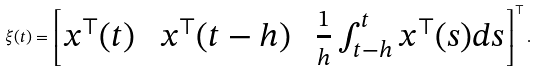<formula> <loc_0><loc_0><loc_500><loc_500>\xi ( t ) = \left [ \begin{matrix} x ^ { \top } ( t ) & \ x ^ { \top } ( t - h ) \ & \frac { 1 } { h } \int _ { t - h } ^ { t } x ^ { \top } ( s ) d s \end{matrix} \right ] ^ { \top } .</formula> 